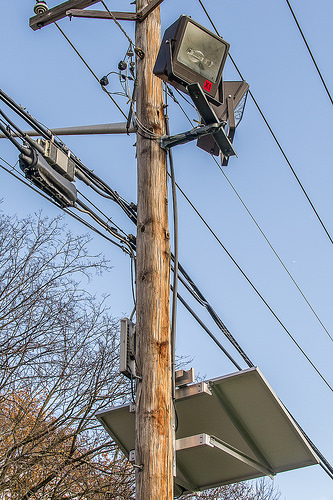<image>
Is the telephone pole behind the power line? No. The telephone pole is not behind the power line. From this viewpoint, the telephone pole appears to be positioned elsewhere in the scene. 